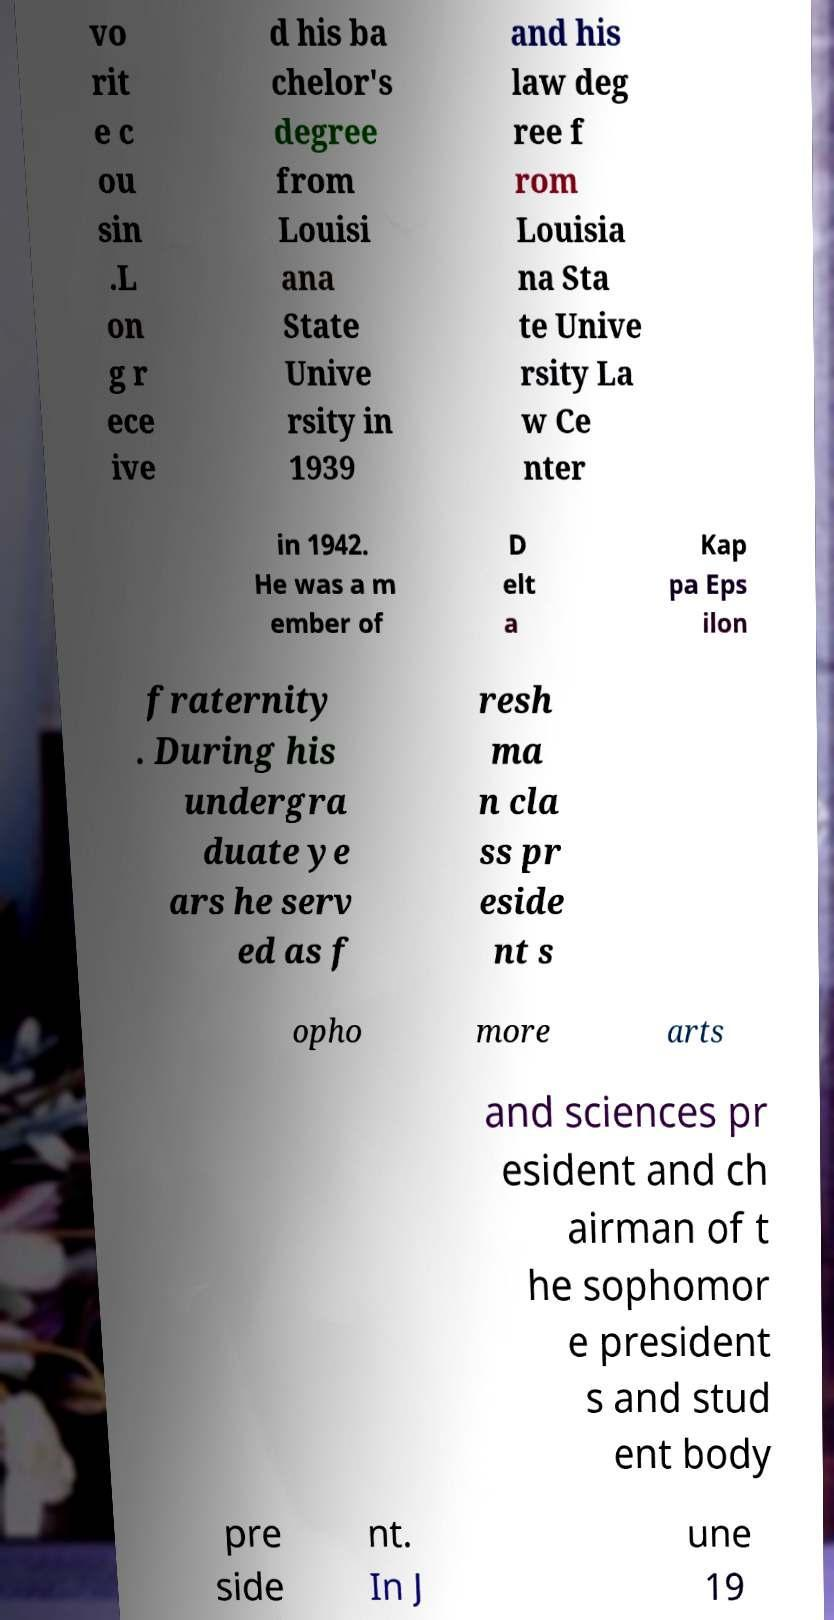Please identify and transcribe the text found in this image. vo rit e c ou sin .L on g r ece ive d his ba chelor's degree from Louisi ana State Unive rsity in 1939 and his law deg ree f rom Louisia na Sta te Unive rsity La w Ce nter in 1942. He was a m ember of D elt a Kap pa Eps ilon fraternity . During his undergra duate ye ars he serv ed as f resh ma n cla ss pr eside nt s opho more arts and sciences pr esident and ch airman of t he sophomor e president s and stud ent body pre side nt. In J une 19 